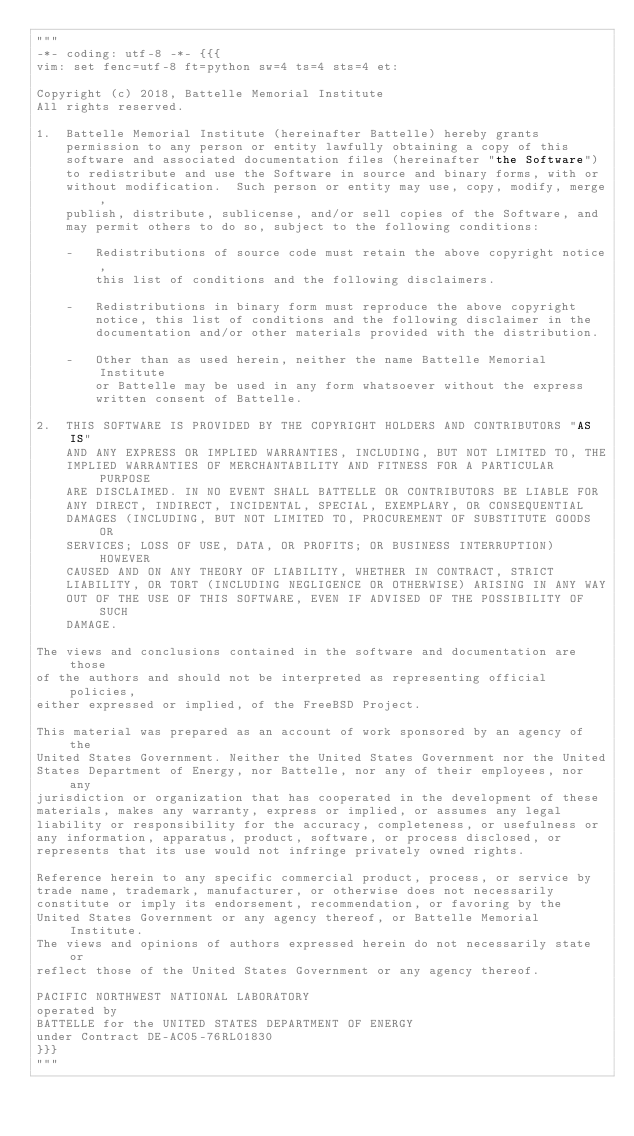<code> <loc_0><loc_0><loc_500><loc_500><_Python_>"""
-*- coding: utf-8 -*- {{{
vim: set fenc=utf-8 ft=python sw=4 ts=4 sts=4 et:

Copyright (c) 2018, Battelle Memorial Institute
All rights reserved.

1.  Battelle Memorial Institute (hereinafter Battelle) hereby grants
    permission to any person or entity lawfully obtaining a copy of this
    software and associated documentation files (hereinafter "the Software")
    to redistribute and use the Software in source and binary forms, with or
    without modification.  Such person or entity may use, copy, modify, merge,
    publish, distribute, sublicense, and/or sell copies of the Software, and
    may permit others to do so, subject to the following conditions:

    -   Redistributions of source code must retain the above copyright notice,
        this list of conditions and the following disclaimers.

    -	Redistributions in binary form must reproduce the above copyright
        notice, this list of conditions and the following disclaimer in the
        documentation and/or other materials provided with the distribution.

    -	Other than as used herein, neither the name Battelle Memorial Institute
        or Battelle may be used in any form whatsoever without the express
        written consent of Battelle.

2.	THIS SOFTWARE IS PROVIDED BY THE COPYRIGHT HOLDERS AND CONTRIBUTORS "AS IS"
    AND ANY EXPRESS OR IMPLIED WARRANTIES, INCLUDING, BUT NOT LIMITED TO, THE
    IMPLIED WARRANTIES OF MERCHANTABILITY AND FITNESS FOR A PARTICULAR PURPOSE
    ARE DISCLAIMED. IN NO EVENT SHALL BATTELLE OR CONTRIBUTORS BE LIABLE FOR
    ANY DIRECT, INDIRECT, INCIDENTAL, SPECIAL, EXEMPLARY, OR CONSEQUENTIAL
    DAMAGES (INCLUDING, BUT NOT LIMITED TO, PROCUREMENT OF SUBSTITUTE GOODS OR
    SERVICES; LOSS OF USE, DATA, OR PROFITS; OR BUSINESS INTERRUPTION) HOWEVER
    CAUSED AND ON ANY THEORY OF LIABILITY, WHETHER IN CONTRACT, STRICT
    LIABILITY, OR TORT (INCLUDING NEGLIGENCE OR OTHERWISE) ARISING IN ANY WAY
    OUT OF THE USE OF THIS SOFTWARE, EVEN IF ADVISED OF THE POSSIBILITY OF SUCH
    DAMAGE.

The views and conclusions contained in the software and documentation are those
of the authors and should not be interpreted as representing official policies,
either expressed or implied, of the FreeBSD Project.

This material was prepared as an account of work sponsored by an agency of the
United States Government. Neither the United States Government nor the United
States Department of Energy, nor Battelle, nor any of their employees, nor any
jurisdiction or organization that has cooperated in the development of these
materials, makes any warranty, express or implied, or assumes any legal
liability or responsibility for the accuracy, completeness, or usefulness or
any information, apparatus, product, software, or process disclosed, or
represents that its use would not infringe privately owned rights.

Reference herein to any specific commercial product, process, or service by
trade name, trademark, manufacturer, or otherwise does not necessarily
constitute or imply its endorsement, recommendation, or favoring by the
United States Government or any agency thereof, or Battelle Memorial Institute.
The views and opinions of authors expressed herein do not necessarily state or
reflect those of the United States Government or any agency thereof.

PACIFIC NORTHWEST NATIONAL LABORATORY
operated by
BATTELLE for the UNITED STATES DEPARTMENT OF ENERGY
under Contract DE-AC05-76RL01830
}}}
"""</code> 